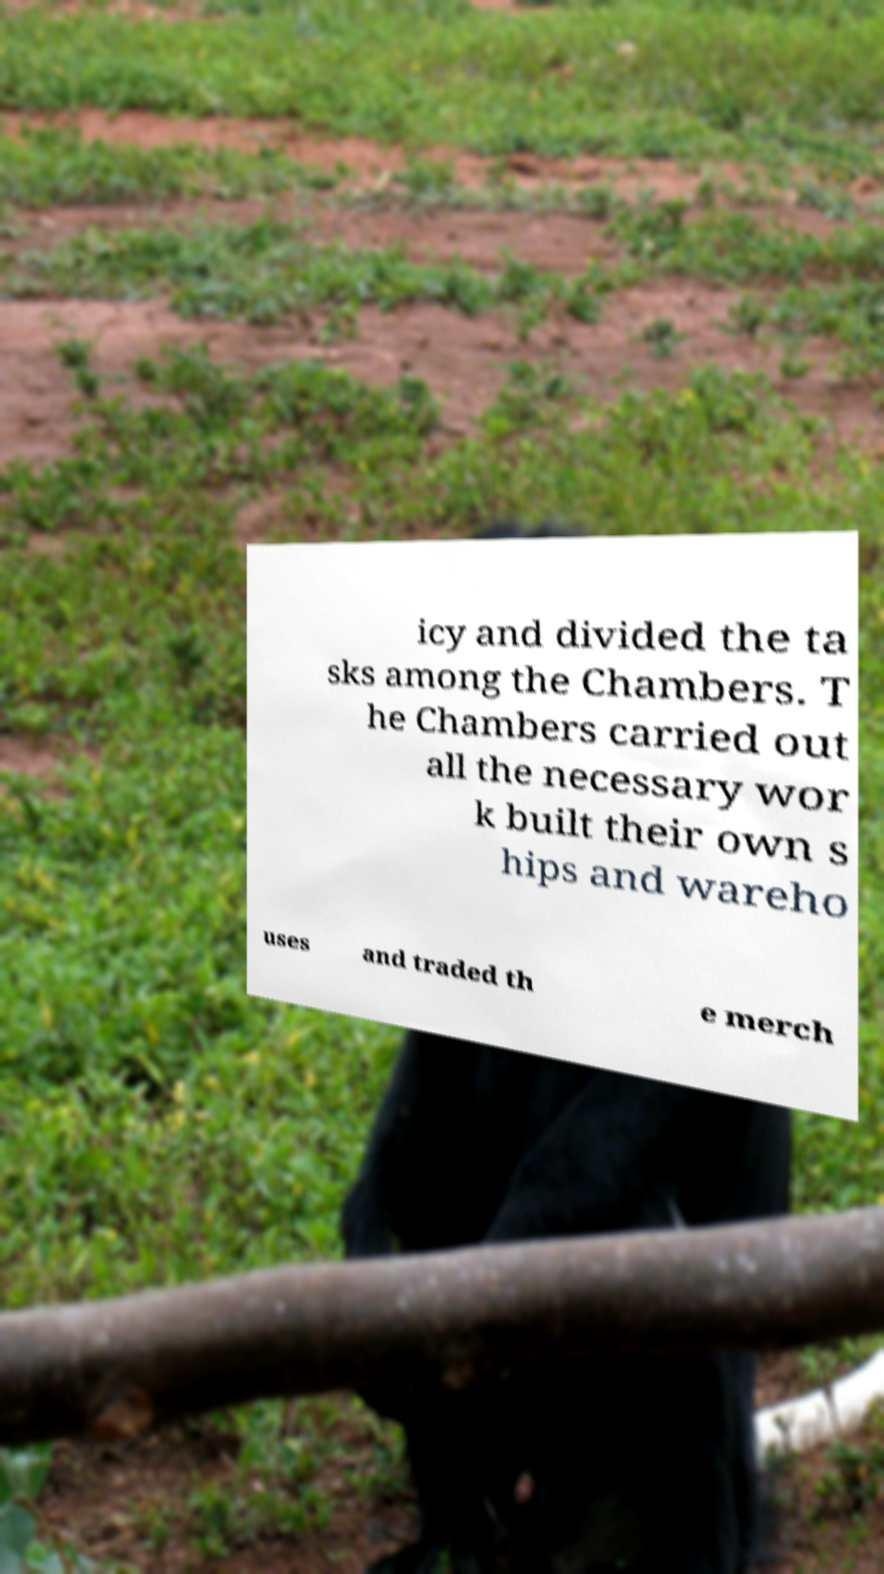What messages or text are displayed in this image? I need them in a readable, typed format. icy and divided the ta sks among the Chambers. T he Chambers carried out all the necessary wor k built their own s hips and wareho uses and traded th e merch 